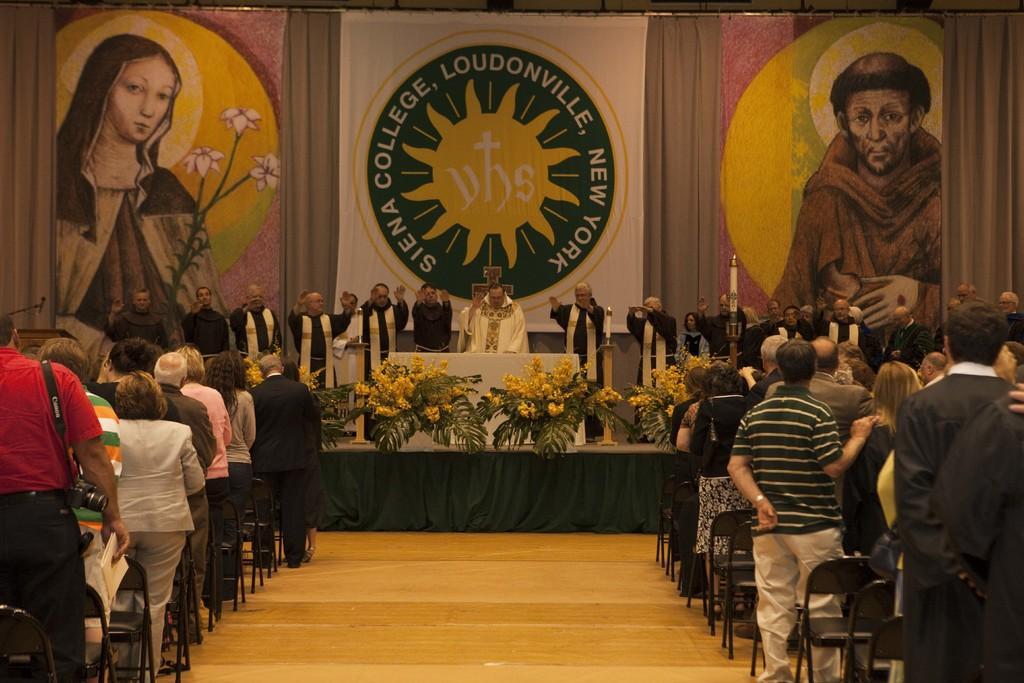Could you give a brief overview of what you see in this image? On the left and right side of the image we can see a few people are standing. Among them, we can see one person is holding an object and he is wearing a camera. And we can see chairs. In the center of the image, there is a stage. On the stage, we can see plants with flowers, one table, candles and a few people are standing. In the background there is a wall with some paintings, in which we can see two persons and some text. 